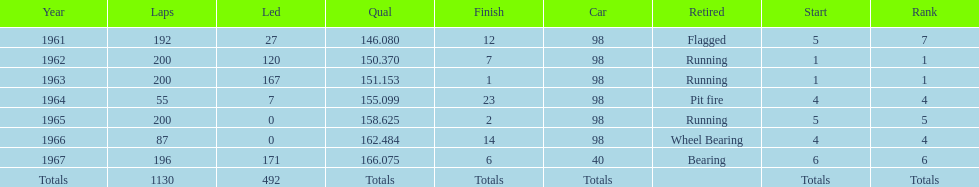Number of times to finish the races running. 3. 